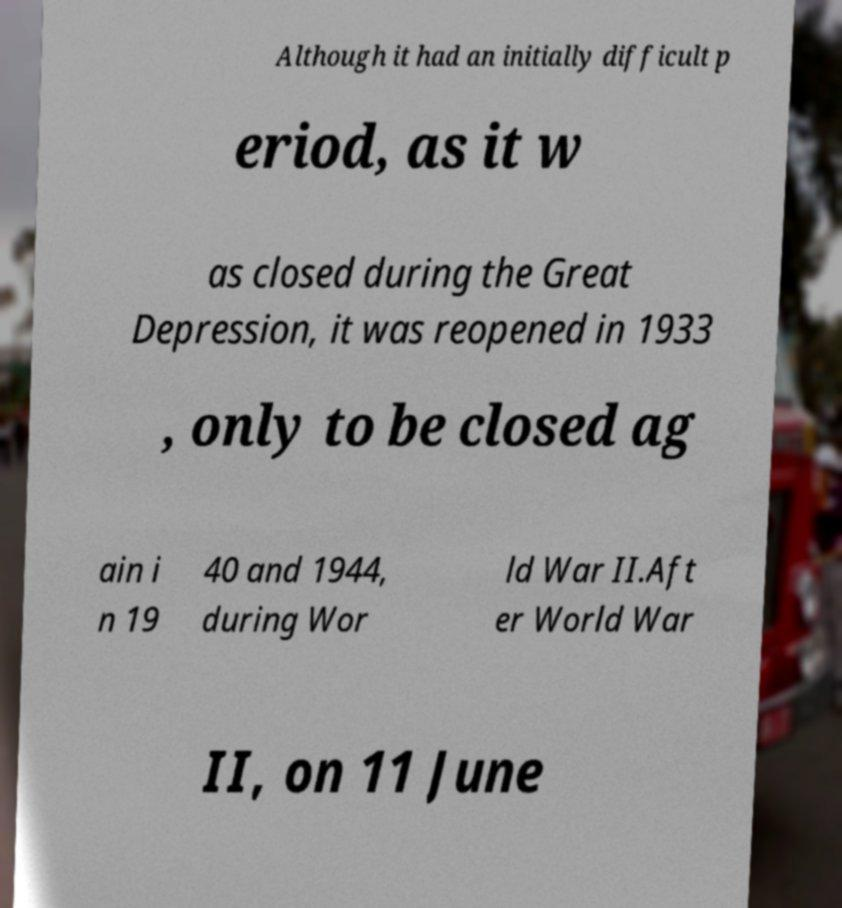For documentation purposes, I need the text within this image transcribed. Could you provide that? Although it had an initially difficult p eriod, as it w as closed during the Great Depression, it was reopened in 1933 , only to be closed ag ain i n 19 40 and 1944, during Wor ld War II.Aft er World War II, on 11 June 